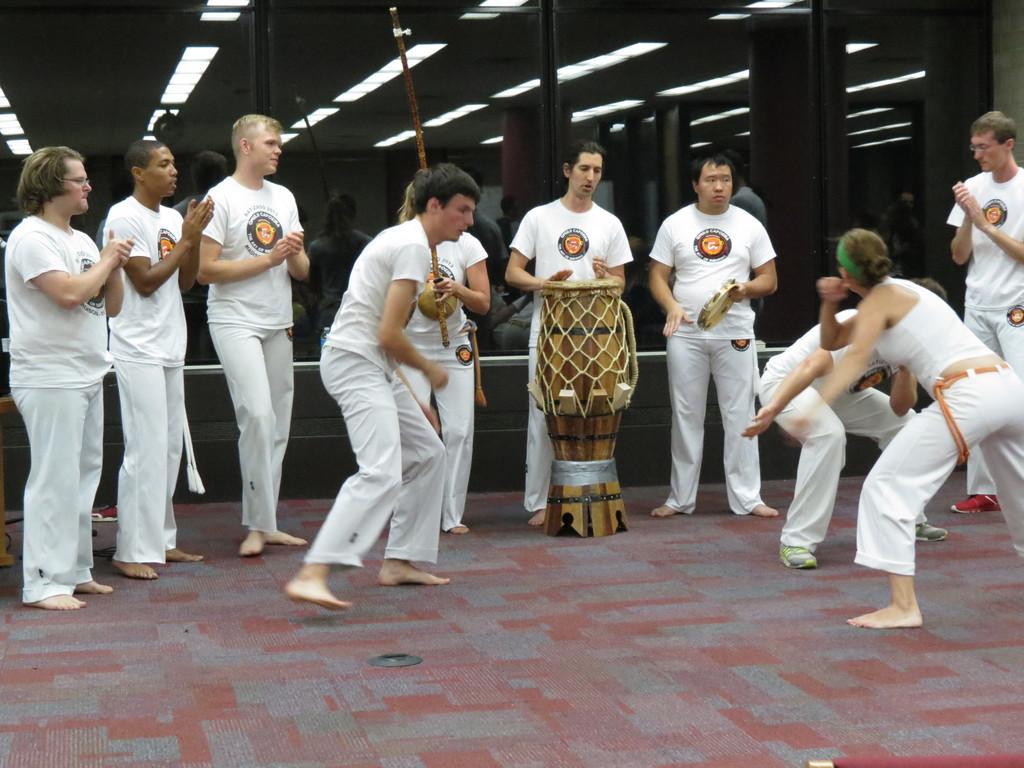Can you describe this image briefly? Here in this picture we can see a group of people standing over a place and they are practicing martial arts over there and the man in the middle is playing drums present in the middle, on the floor and we can see lights present on the roof. 